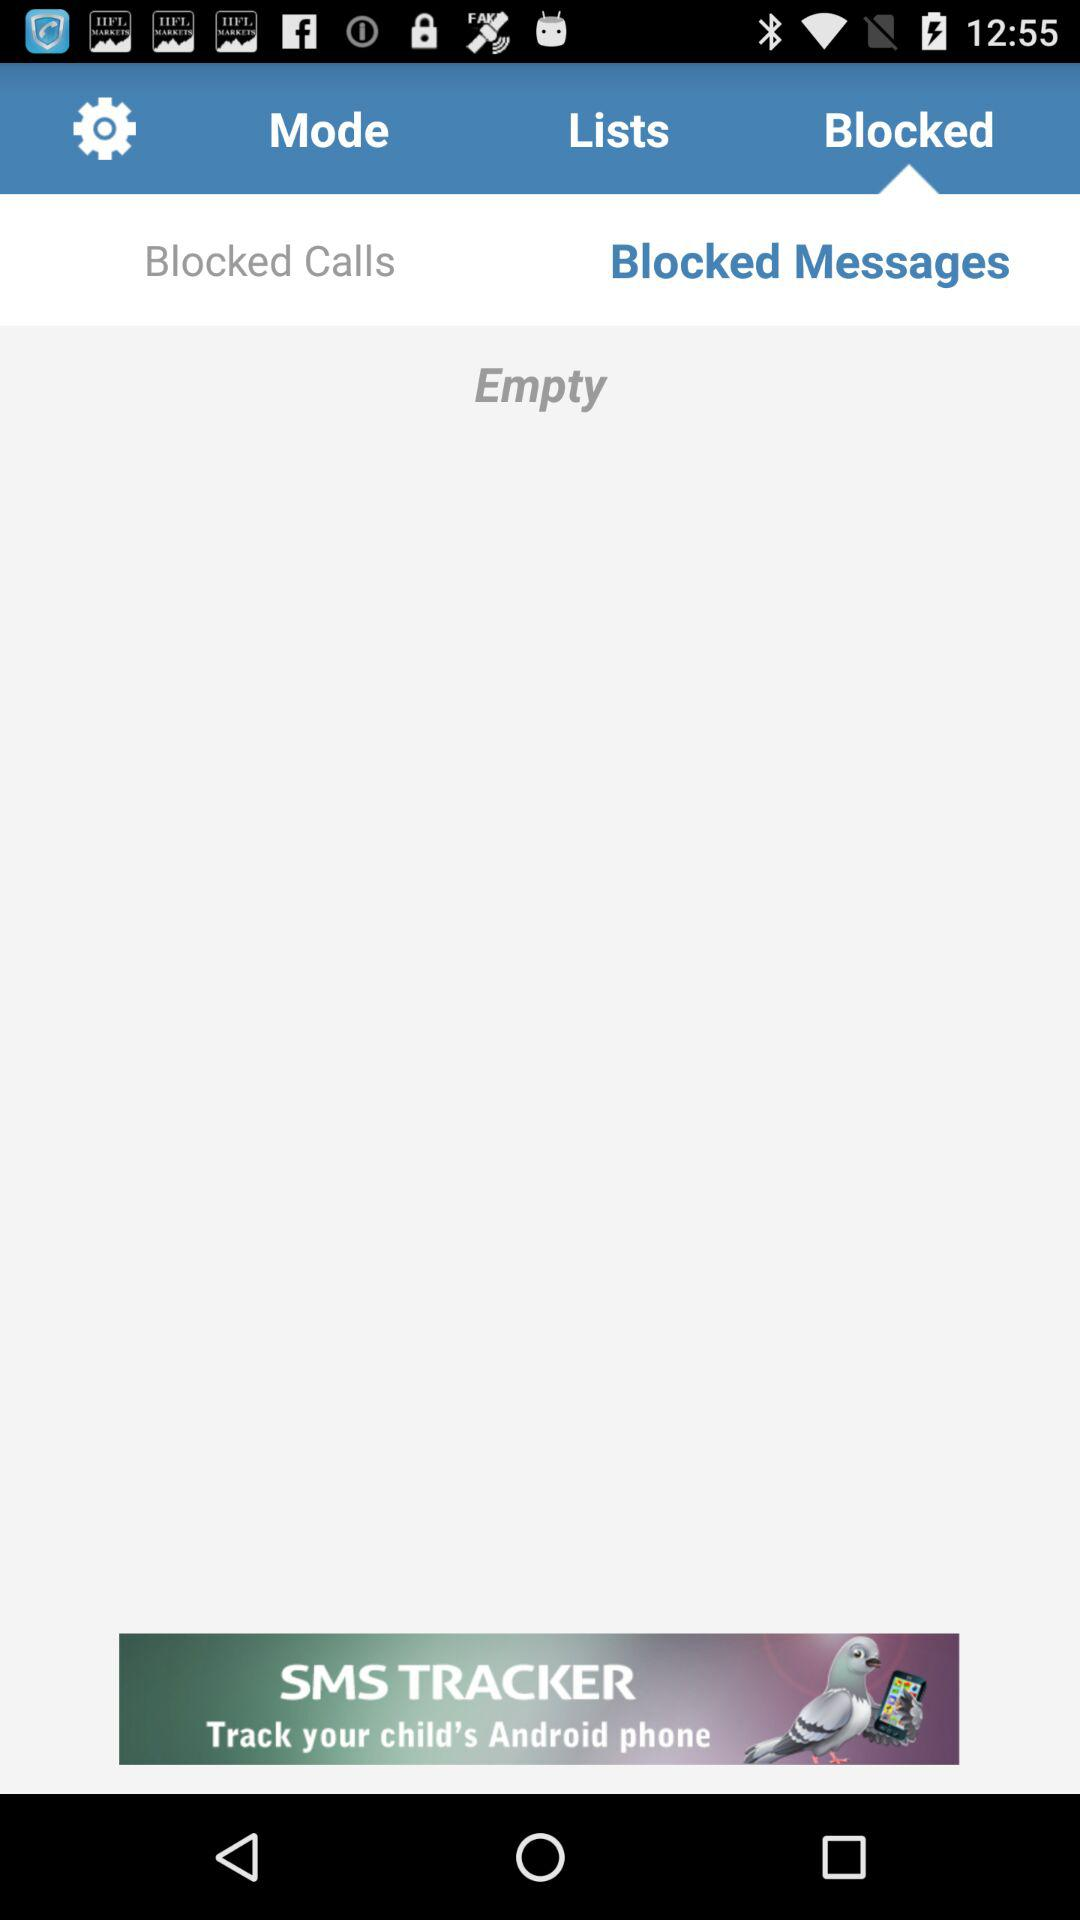Which tab am I on? You are on the "Blocked" and "Blocked Messages" tabs. 